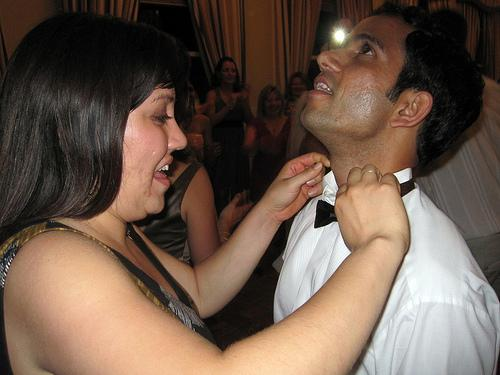What kind of event is taking place in the image? A dance party is happening in the image. What are the main colors of elements in this image, such as clothing, background, and the room? Main colors in the image include black (bowtie), white (shirt and curtain), dark (windows and hair), and pink (lips). Identify the primary focus of the image and describe their appearance. The primary focus is a man and a woman. The man is wearing a white shirt with wrinkles, and black bowtie, has dark hair, and is looking up. The woman has dark hair, wears a sleeveless dress with a deep V-neck, and has pink lips. What is the color of the shirt of the man in viewport and what's its condition? The man's shirt is white, and it has wrinkles. Is there any accessory the woman is wearing? The woman is wearing a ring on her finger. How many people can be seen clapping in the background of this image? A group of partyers is clapping in the background. Provide a short description of the primary scene depicted in the image. A man and a woman at a party, with the woman adjusting the man's bowtie while he looks up, and people clapping in the background. Describe the state of the man's mouth and eyes. The man's mouth is open, and his eye is looking down. What activity is the woman engaged in? The woman is adjusting the man's bowtie. What type of clothing attire is the woman wearing? The woman is wearing a sleeveless dress with a deep V-neck. 